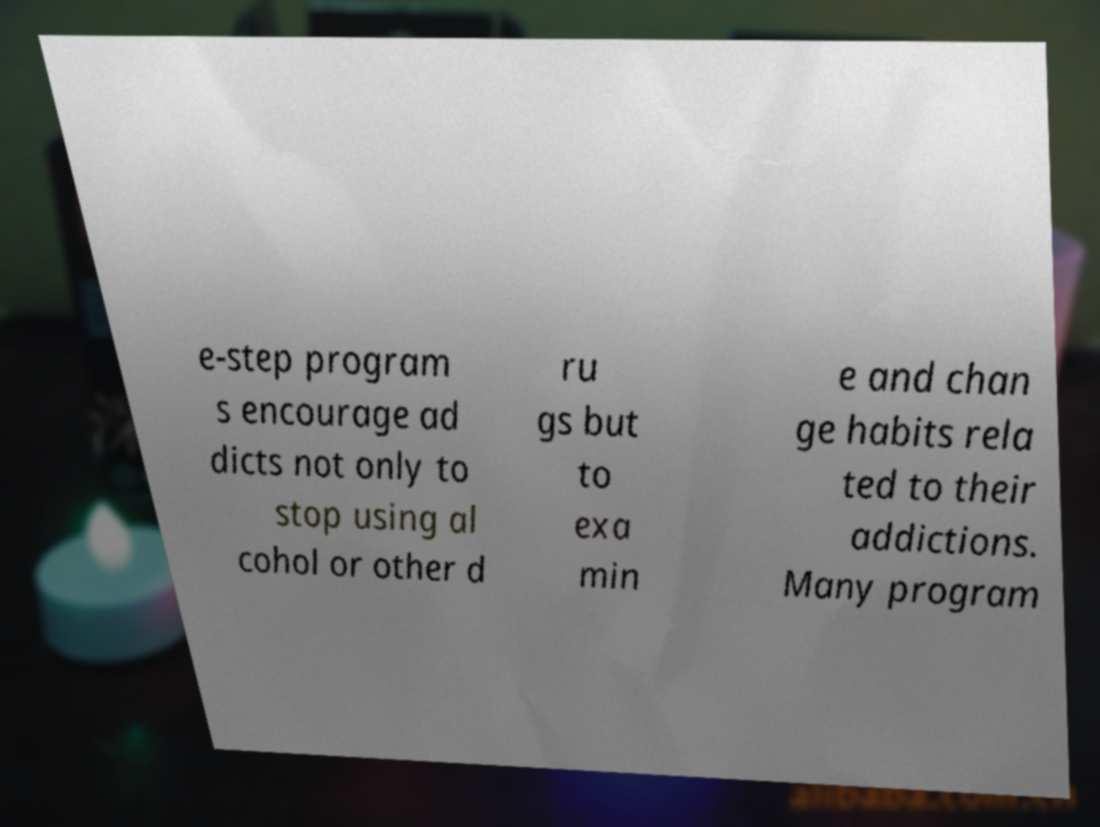Could you extract and type out the text from this image? e-step program s encourage ad dicts not only to stop using al cohol or other d ru gs but to exa min e and chan ge habits rela ted to their addictions. Many program 